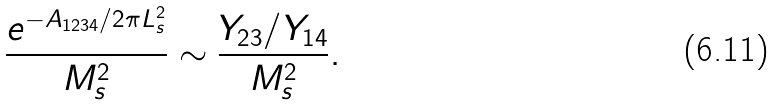Convert formula to latex. <formula><loc_0><loc_0><loc_500><loc_500>\frac { e ^ { - A _ { 1 2 3 4 } / 2 \pi L _ { s } ^ { 2 } } } { M _ { s } ^ { 2 } } \sim \frac { Y _ { 2 3 } / Y _ { 1 4 } } { M _ { s } ^ { 2 } } .</formula> 